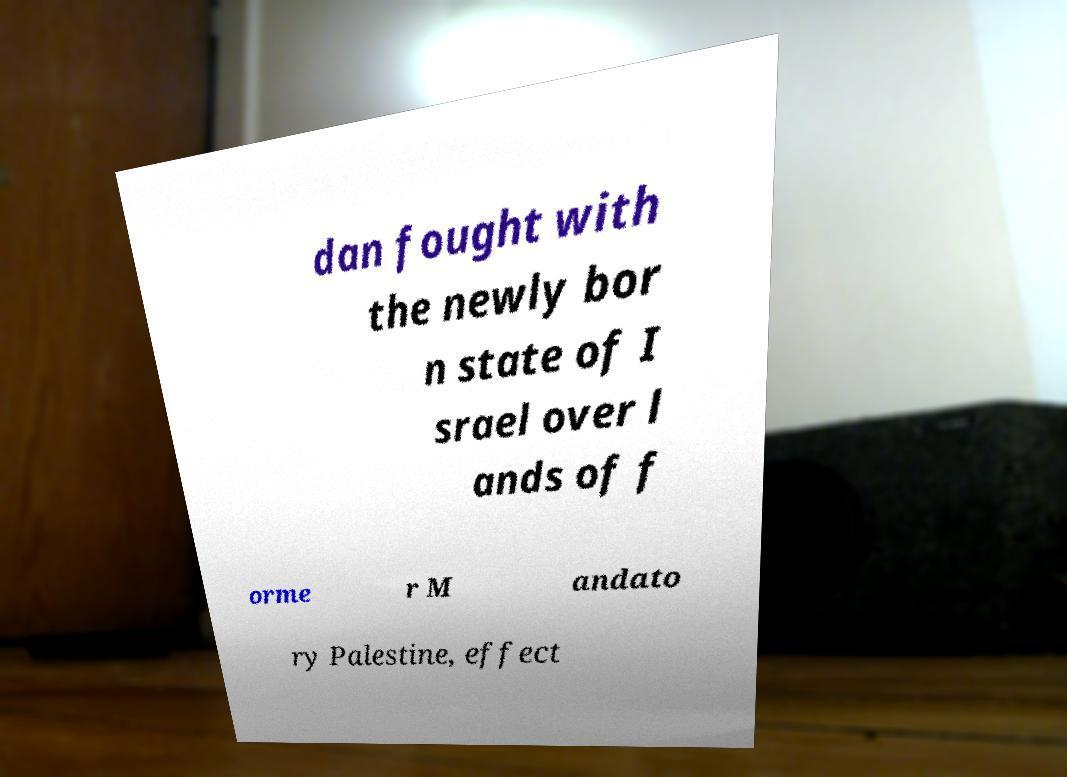There's text embedded in this image that I need extracted. Can you transcribe it verbatim? dan fought with the newly bor n state of I srael over l ands of f orme r M andato ry Palestine, effect 